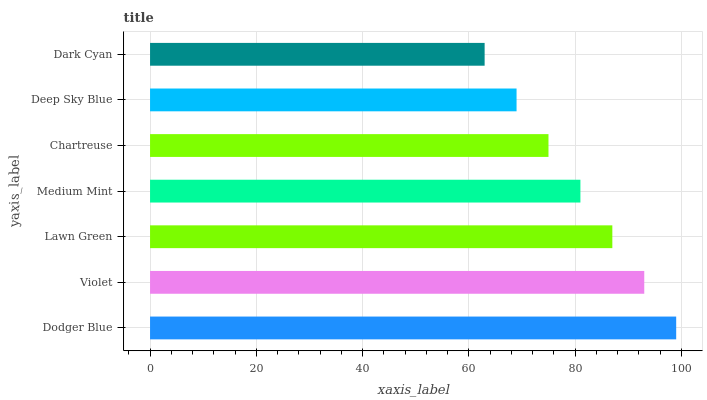Is Dark Cyan the minimum?
Answer yes or no. Yes. Is Dodger Blue the maximum?
Answer yes or no. Yes. Is Violet the minimum?
Answer yes or no. No. Is Violet the maximum?
Answer yes or no. No. Is Dodger Blue greater than Violet?
Answer yes or no. Yes. Is Violet less than Dodger Blue?
Answer yes or no. Yes. Is Violet greater than Dodger Blue?
Answer yes or no. No. Is Dodger Blue less than Violet?
Answer yes or no. No. Is Medium Mint the high median?
Answer yes or no. Yes. Is Medium Mint the low median?
Answer yes or no. Yes. Is Chartreuse the high median?
Answer yes or no. No. Is Deep Sky Blue the low median?
Answer yes or no. No. 